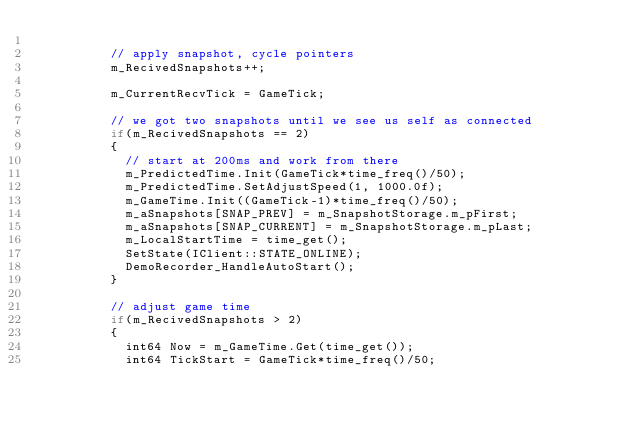Convert code to text. <code><loc_0><loc_0><loc_500><loc_500><_C++_>
					// apply snapshot, cycle pointers
					m_RecivedSnapshots++;

					m_CurrentRecvTick = GameTick;

					// we got two snapshots until we see us self as connected
					if(m_RecivedSnapshots == 2)
					{
						// start at 200ms and work from there
						m_PredictedTime.Init(GameTick*time_freq()/50);
						m_PredictedTime.SetAdjustSpeed(1, 1000.0f);
						m_GameTime.Init((GameTick-1)*time_freq()/50);
						m_aSnapshots[SNAP_PREV] = m_SnapshotStorage.m_pFirst;
						m_aSnapshots[SNAP_CURRENT] = m_SnapshotStorage.m_pLast;
						m_LocalStartTime = time_get();
						SetState(IClient::STATE_ONLINE);
						DemoRecorder_HandleAutoStart();
					}

					// adjust game time
					if(m_RecivedSnapshots > 2)
					{
						int64 Now = m_GameTime.Get(time_get());
						int64 TickStart = GameTick*time_freq()/50;</code> 